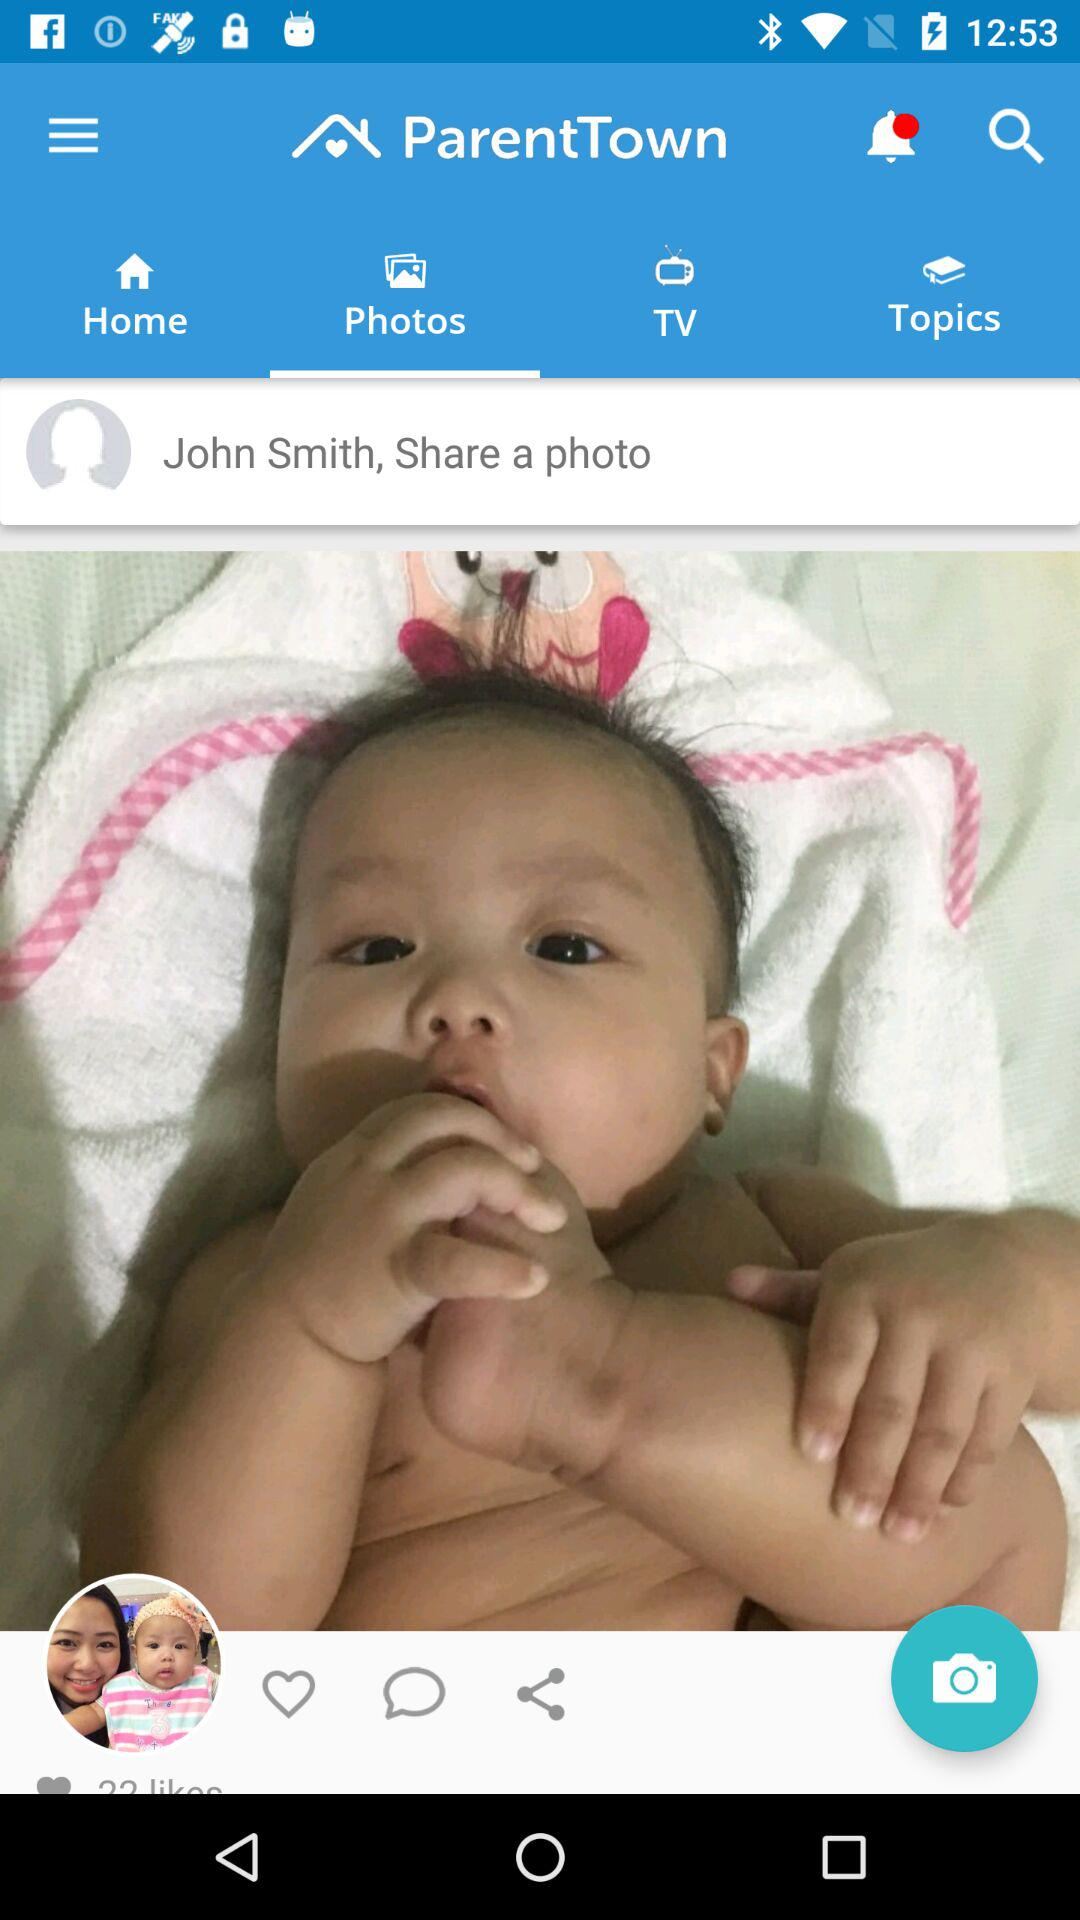What is the name of the user? The name of the user is "John Smith". 